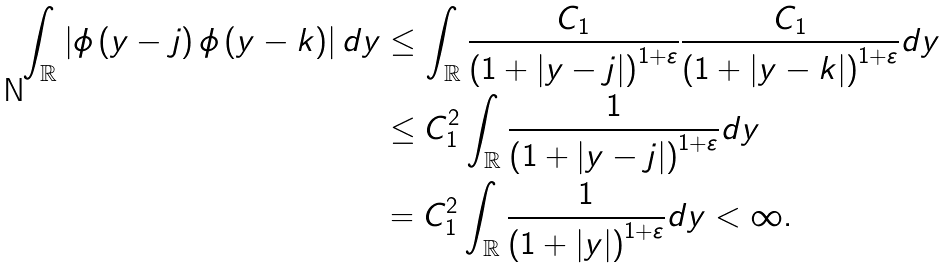<formula> <loc_0><loc_0><loc_500><loc_500>\int _ { \mathbb { R } } \left | \phi \left ( y - j \right ) \phi \left ( y - k \right ) \right | d y & \leq \int _ { \mathbb { R } } \frac { C _ { 1 } } { \left ( 1 + \left | y - j \right | \right ) ^ { 1 + \varepsilon } } \frac { C _ { 1 } } { \left ( 1 + \left | y - k \right | \right ) ^ { 1 + \varepsilon } } d y \\ & \leq C _ { 1 } ^ { 2 } \int _ { \mathbb { R } } \frac { 1 } { \left ( 1 + \left | y - j \right | \right ) ^ { 1 + \varepsilon } } d y \\ & = C _ { 1 } ^ { 2 } \int _ { \mathbb { R } } \frac { 1 } { \left ( 1 + \left | y \right | \right ) ^ { 1 + \varepsilon } } d y < \infty .</formula> 